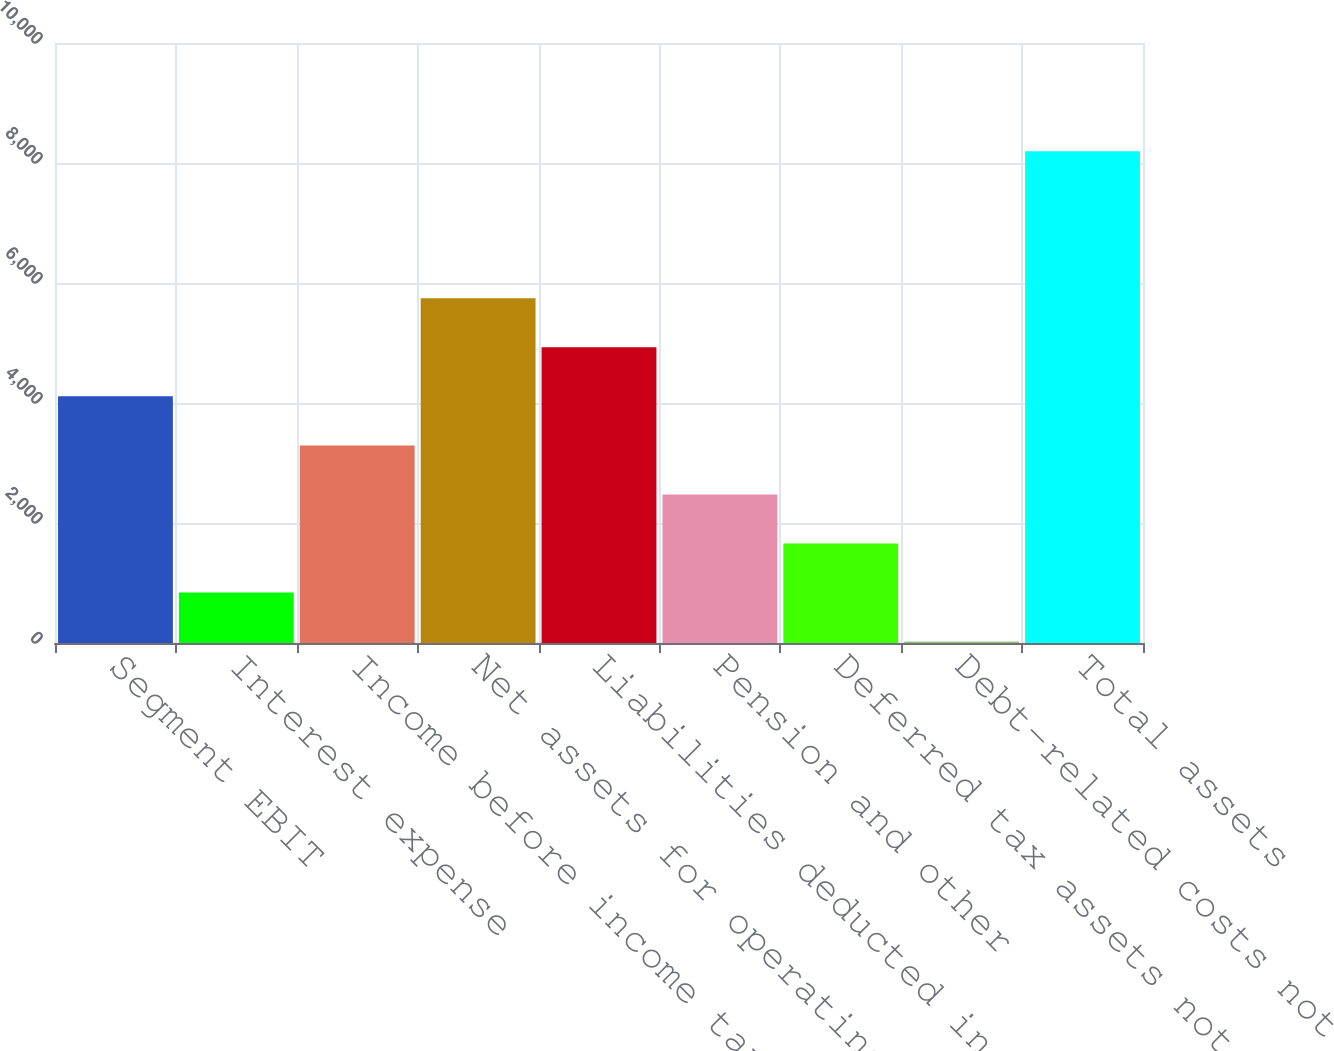Convert chart to OTSL. <chart><loc_0><loc_0><loc_500><loc_500><bar_chart><fcel>Segment EBIT<fcel>Interest expense<fcel>Income before income taxes and<fcel>Net assets for operating<fcel>Liabilities deducted in<fcel>Pension and other<fcel>Deferred tax assets not<fcel>Debt-related costs not<fcel>Total assets<nl><fcel>4110.5<fcel>842.9<fcel>3293.6<fcel>5744.3<fcel>4927.4<fcel>2476.7<fcel>1659.8<fcel>26<fcel>8195<nl></chart> 